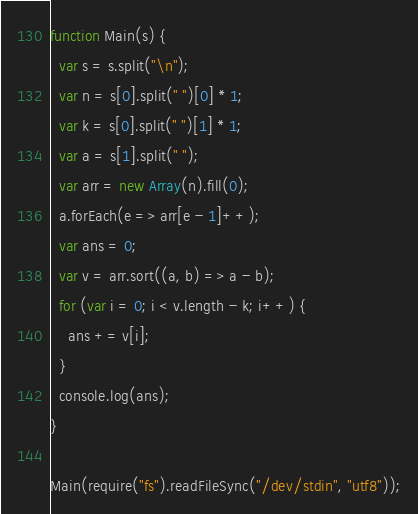<code> <loc_0><loc_0><loc_500><loc_500><_JavaScript_>function Main(s) {
  var s = s.split("\n");
  var n = s[0].split(" ")[0] * 1;
  var k = s[0].split(" ")[1] * 1;
  var a = s[1].split(" ");
  var arr = new Array(n).fill(0);
  a.forEach(e => arr[e - 1]++);
  var ans = 0;
  var v = arr.sort((a, b) => a - b);
  for (var i = 0; i < v.length - k; i++) {
    ans += v[i];
  }
  console.log(ans);
}

Main(require("fs").readFileSync("/dev/stdin", "utf8"));</code> 